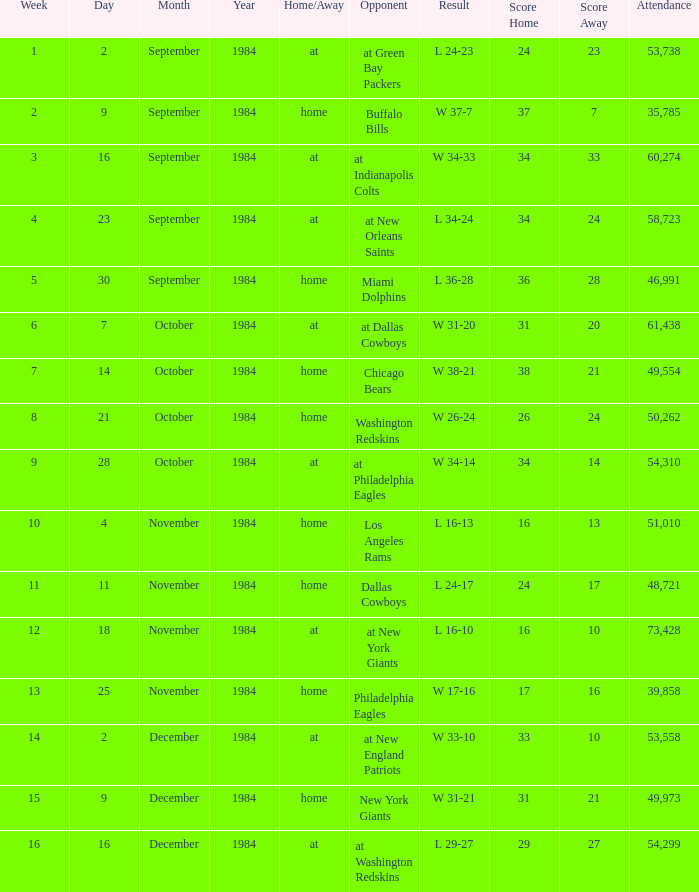What is the sum of attendance when the result was l 16-13? 51010.0. 